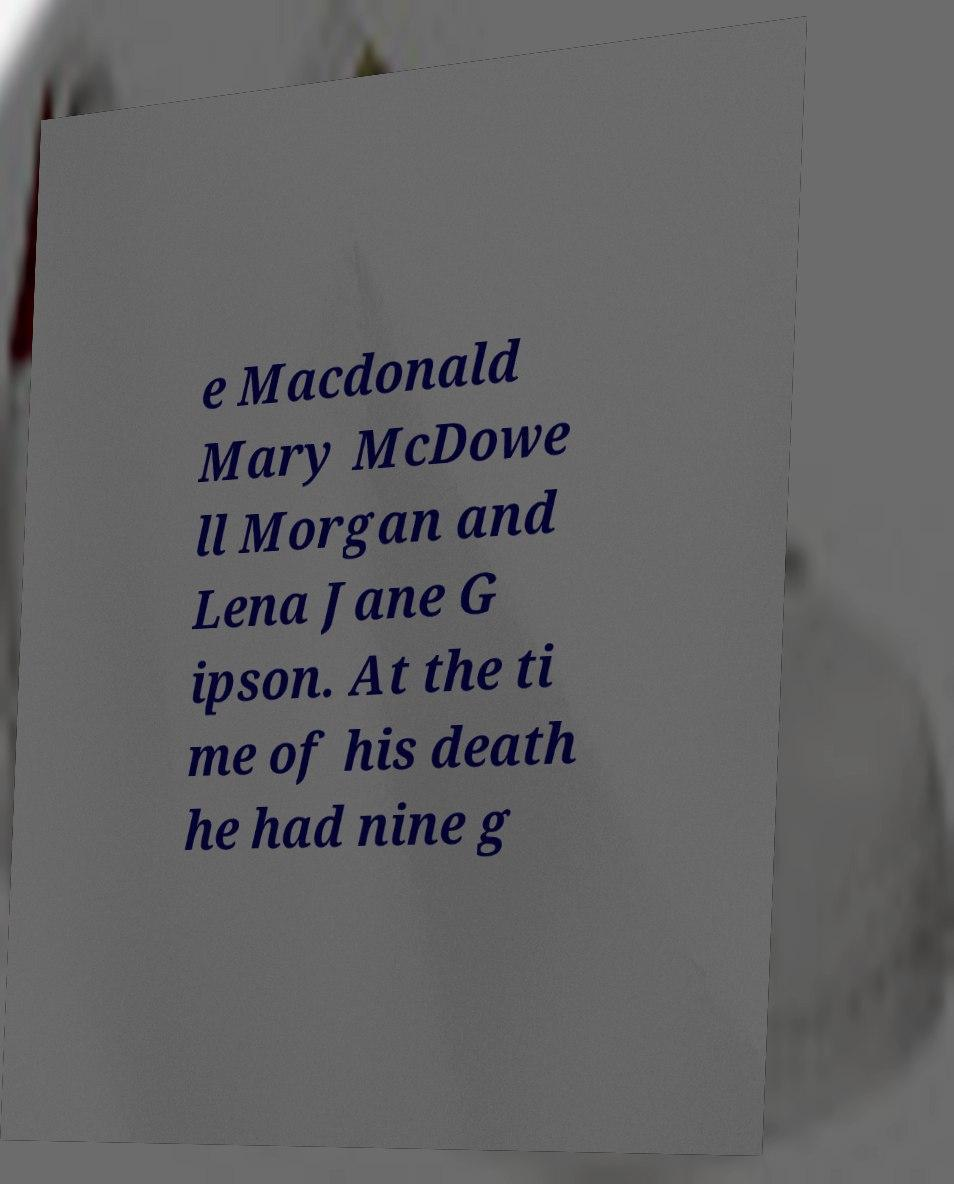I need the written content from this picture converted into text. Can you do that? e Macdonald Mary McDowe ll Morgan and Lena Jane G ipson. At the ti me of his death he had nine g 